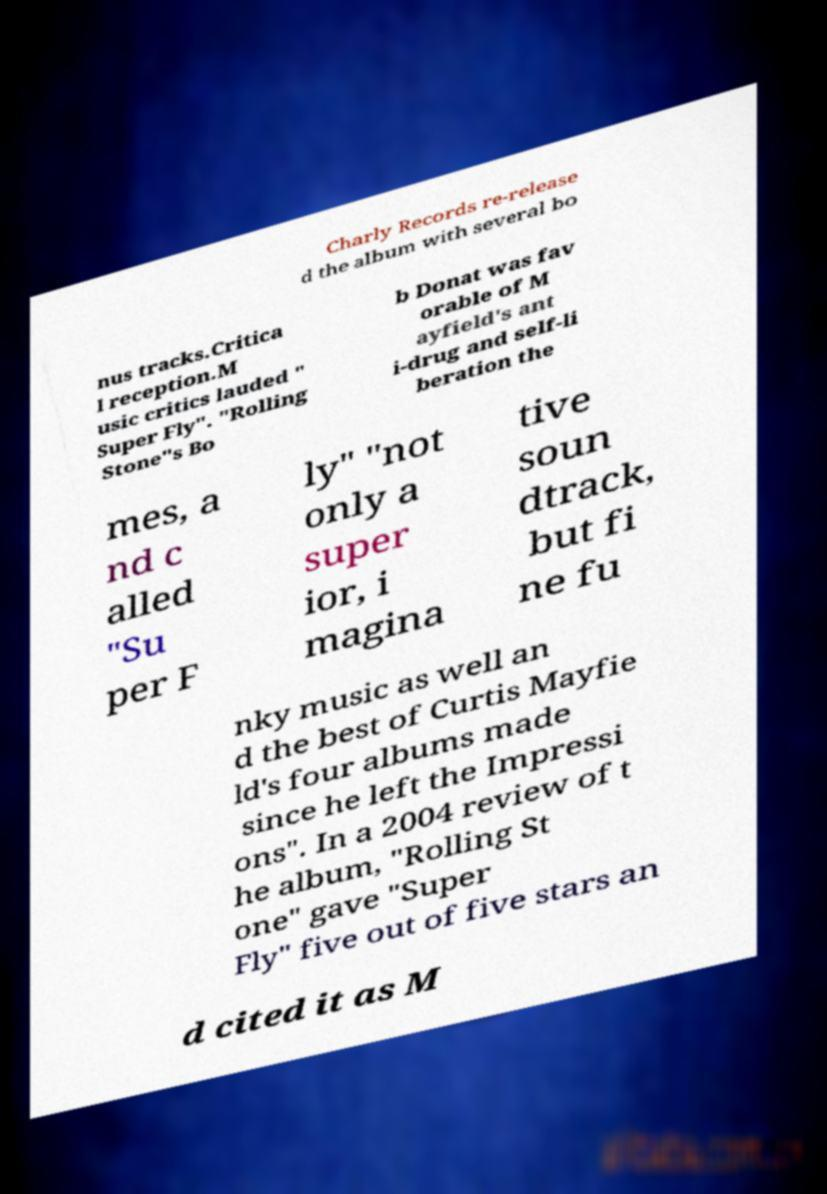Please read and relay the text visible in this image. What does it say? Charly Records re-release d the album with several bo nus tracks.Critica l reception.M usic critics lauded " Super Fly". "Rolling Stone"s Bo b Donat was fav orable of M ayfield's ant i-drug and self-li beration the mes, a nd c alled "Su per F ly" "not only a super ior, i magina tive soun dtrack, but fi ne fu nky music as well an d the best of Curtis Mayfie ld's four albums made since he left the Impressi ons". In a 2004 review of t he album, "Rolling St one" gave "Super Fly" five out of five stars an d cited it as M 